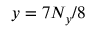<formula> <loc_0><loc_0><loc_500><loc_500>y = 7 N _ { y } / 8</formula> 